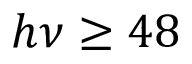<formula> <loc_0><loc_0><loc_500><loc_500>h \nu \geq 4 8</formula> 